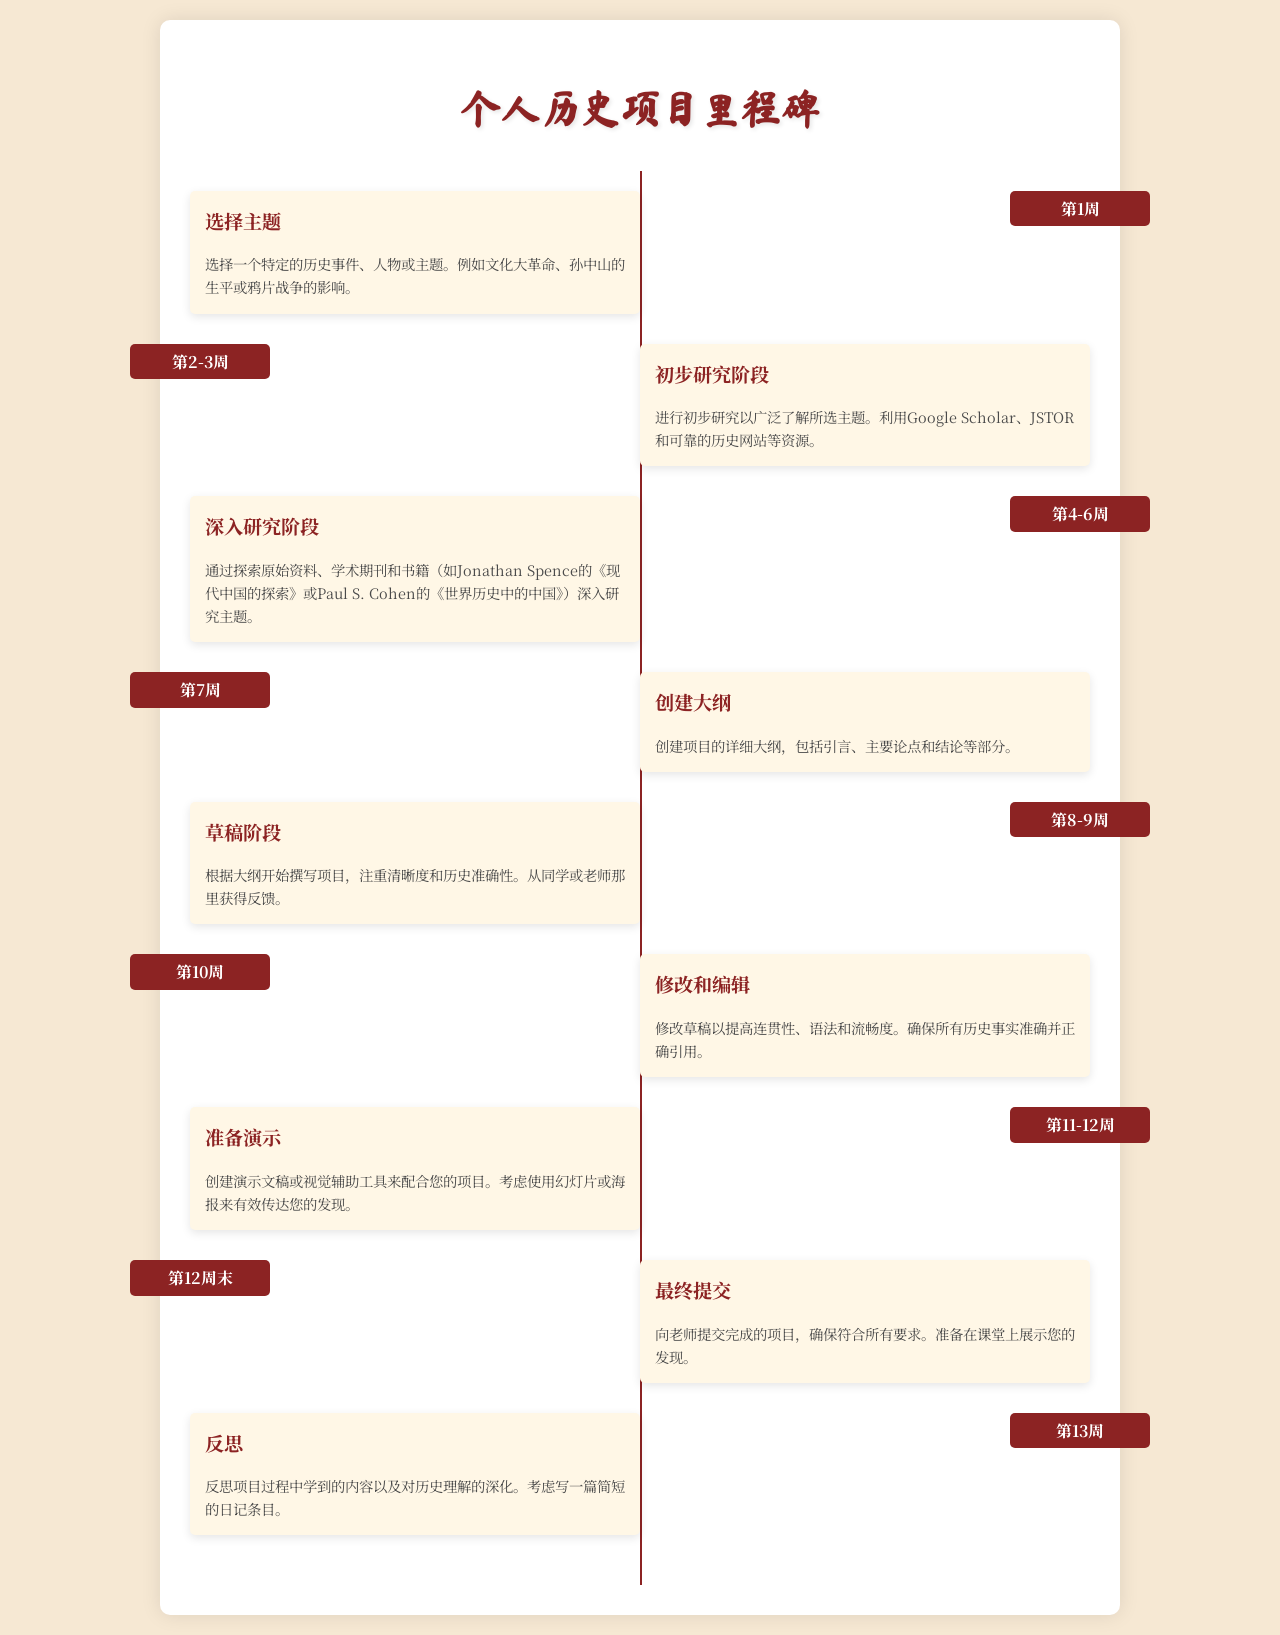what is the first milestone? The first milestone is about selecting a topic for the personal history project.
Answer: 选择主题 how many weeks does the initial research stage last? The initial research stage lasts for 2-3 weeks according to the timeline.
Answer: 2-3周 what is the focus of the 4-6 week research phase? The focus of the 4-6 week research phase is on in-depth exploration of the selected topic.
Answer: 深入研究阶段 what should be created in the 7th week? A detailed outline of the project should be created in the 7th week.
Answer: 创建大纲 what is the final milestone before submission? The final milestone before submission involves preparing for the presentation.
Answer: 准备演示 how many weeks are allocated for drafting the project? The timeline allocates 2 weeks for the drafting phase of the project.
Answer: 2周 which week is designated for reflection on the project? Reflection on the project is designated for the 13th week.
Answer: 第13周 what is the primary purpose of the project presentation? The primary purpose of the project presentation is to effectively convey your findings.
Answer: 有效传达您的发现 what resource types are suggested for initial research? Google Scholar, JSTOR, and reliable historical websites are suggested resources.
Answer: 可靠的历史网站 